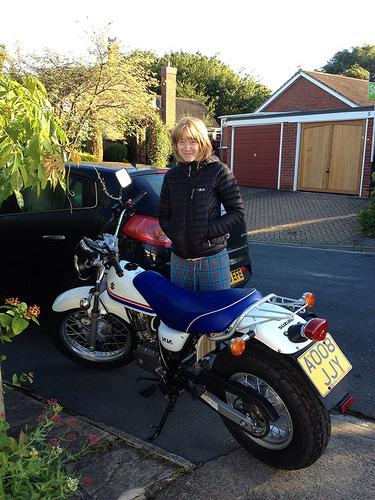Write a headline for the image, capturing its main focus. "Young Fashionista Pauses Alongside Colorful Motorcycle on Brick House Backdrop" Mention the main subjects in the image and their surroundings. A girl wearing a black hoodie and plaid skirt stands beside a white, blue, and red motorcycle parked on a faded brick driveway in front of a red house with a tan wooden door. List the top 3 most eye-catching items in the image, in no particular order. White, blue, and red motorcycle; girl in black hoodie and plaid skirt; red house with tan wooden door. Explain the primary subject and the secondary subject observed in the image. The primary subject is a white, blue, and red motorcycle with a yellow license plate, while the secondary subject is a girl in a black hoodie and plaid skirt standing next to it. Write a poetic description of the main elements in this image. Astride the pavement cracked and worn, amongst flowers pink and petals torn, a motorcycle with hues vibrant reigns, and a watchful girl, its sole companion remains. Describe the main subject in the image followed by the key details. A white, blue, and red motorcycle stands parked with a young person beside, featuring a yellow license plate, blue seat, and resting on its kickstand. Explain what one would first notice when looking at the image. Upon looking at the image, one immediately notices the girl standing next to a white, blue, and red motorcycle parked on a cracked pavement driveway. Describe the image as if you were telling a friend what you saw in a photograph. In this picture, I see a girl in a black hoodie and plaid skirt standing next to a cool white, blue, and red motorcycle parked on a brick driveway in front of a red house. Identify the primary object in the image and its most distinctive features. The primary object is a white, blue, and red motorcycle with a yellow license plate, blue seat, rear wheel, and a kickstand. Provide a brief summary of the scene depicted in the image. A young person in a black hoodie and plaid skirt stands next to a parked white, blue, and red motorcycle with a yellow license plate in front of a brick house with a tan wooden door. Notice the grey car parked behind the girl with tinted windows. The existing car is black, not grey, and there is no mention of tinted windows. Find the orange house with a black wooden door in the background. The existing object is a red house with a tan wooden door, not an orange house with a black wooden door. Look for a man standing next to the motorcycle wearing a black jacket and a red hat. A girl is mentioned standing next to the motorcycle, not a man, and there is no mention of a red hat. Can you see the blue wooden doors in the background? The existing wooden doors are described as tan, not blue. The motorcycle has a green license plate attached to its front. The existing license plate is described as yellow and is located on the rear of the motorcycle, not the front. Spot the orange and purple striped shirt worn by the person next to the motorcycle. No, it's not mentioned in the image. The person next to the motorcycle is holding a skateboard. There is no mention of the person holding a skateboard in the given information. Locate the bright blue flowers growing by the sidewalk. The existing flowers are pink, not bright blue. Can you find the green motorcycle parked on the street? The existing object is a white motorcycle with red and blue stripes, not green. Is there a bush with yellow berries in the foreground? The existing plant has red berries, not yellow berries. 